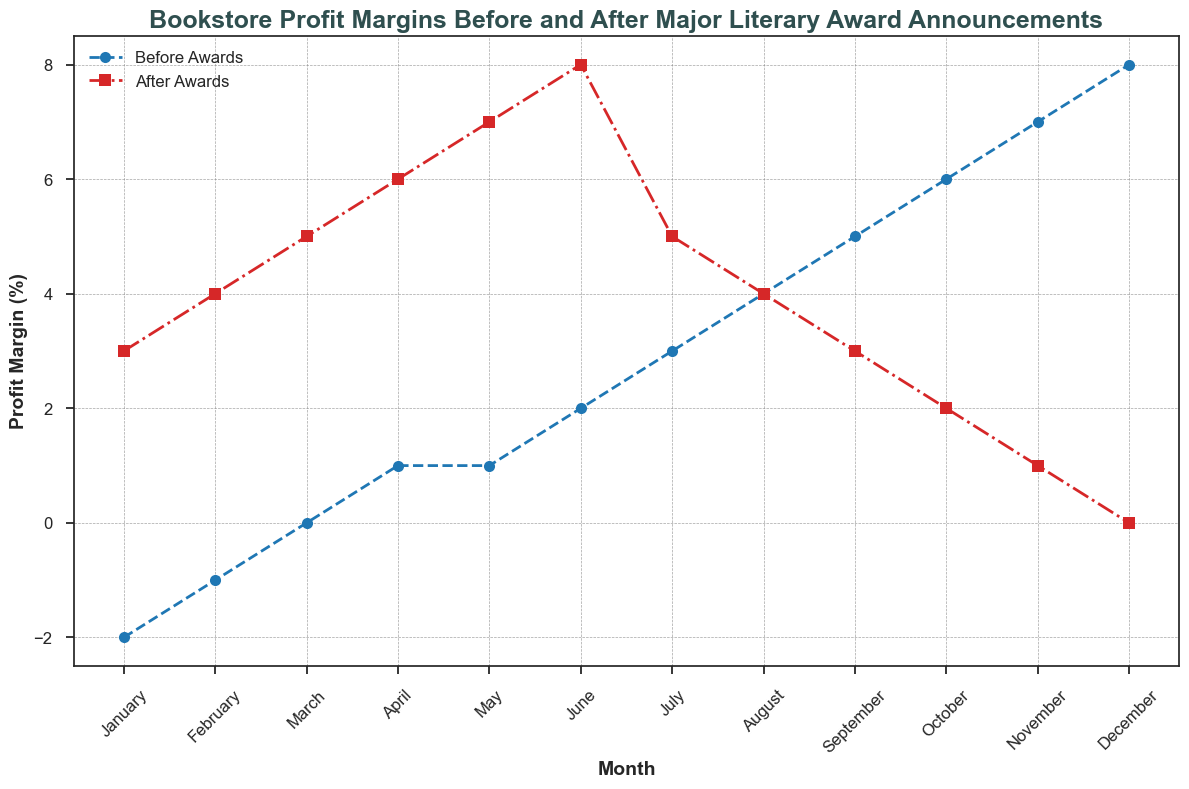How does the profit margin in January before awards compare to the profit margin in January after awards? In the figure, the profit margin in January before awards is -2% and after awards is 3%, showing that the profit margin is higher after the awards.
Answer: 3% higher after awards What is the difference between the highest profit margin before awards and the highest profit margin after awards? The highest profit margin before awards is 8% (in December) and the highest after awards is 8% (in June). The difference is 8 - 8 = 0%.
Answer: 0% Which month shows the greatest increase in profit margins after awards compared to before awards? By visually comparing each month, the greatest increase is in May, where the profit margin increases from 1% before awards to 7% after awards. The difference is 7 - 1 = 6%.
Answer: May In which month are the profit margins before and after awards equal? By examining the two lines on the plot, the profit margins are equal in August, where both values are 4%.
Answer: August On average, how do the profit margins before awards compare to those after awards across the year? To find the average, add up all the monthly profit margins before and after awards, then divide by the number of months. Before awards: (-2) + (-1) + 0 + 1 + 1 + 2 + 3 + 4 + 5 + 6 + 7 + 8 = 34. After awards: 3 + 4 + 5 + 6 + 7 + 8 + 5 + 4 + 3 + 2 + 1 + 0 = 48. Average before awards: 34/12 ≈ 2.83%, Average after awards: 48/12 = 4%.
Answer: 2.83% before, 4% after Which month has the lowest profit margin after the awards, and what is its value? By observing the plot, the lowest profit margin after the awards is in December, with a value of 0%.
Answer: December, 0% What is the median profit margin before awards and how do you find it visually? The median is the middle value in an ordered list. Before awards margins ordered: -2, -1, 0, 1, 1, 2, 3, 4, 5, 6, 7, 8. The median is the average of the 6th and 7th values: (2 + 3)/2 = 2.5.
Answer: 2.5% How does the trend of profit margins before awards compare to the trend after awards throughout the year? Before awards, the trend is a steady increase from -2% to 8%. After awards, the trend is an increase from 3% to 8% by June, followed by a gradual decrease to 0% in December.
Answer: Steady increase before, increase then decrease after What's the total profit margin increase from January to June before the awards? Calculate the difference between January and June profit margins before awards: February profit margin - January profit margin + ... + June profit margin - May profit margin = 2 - (-2) = 4, 1 - (-1) = 2, 1 - 0 = 1, 2 - 1 = 1. So total increase 2+2+1+1=6%.
Answer: 6% Which month's profit margin after awards had the smallest change compared to before awards, and what was the change? Find the months where the difference between profit margin before and after awards is smallest. August shows 4% before awards and 4% after awards, so the change is 0%.
Answer: August, 0% 